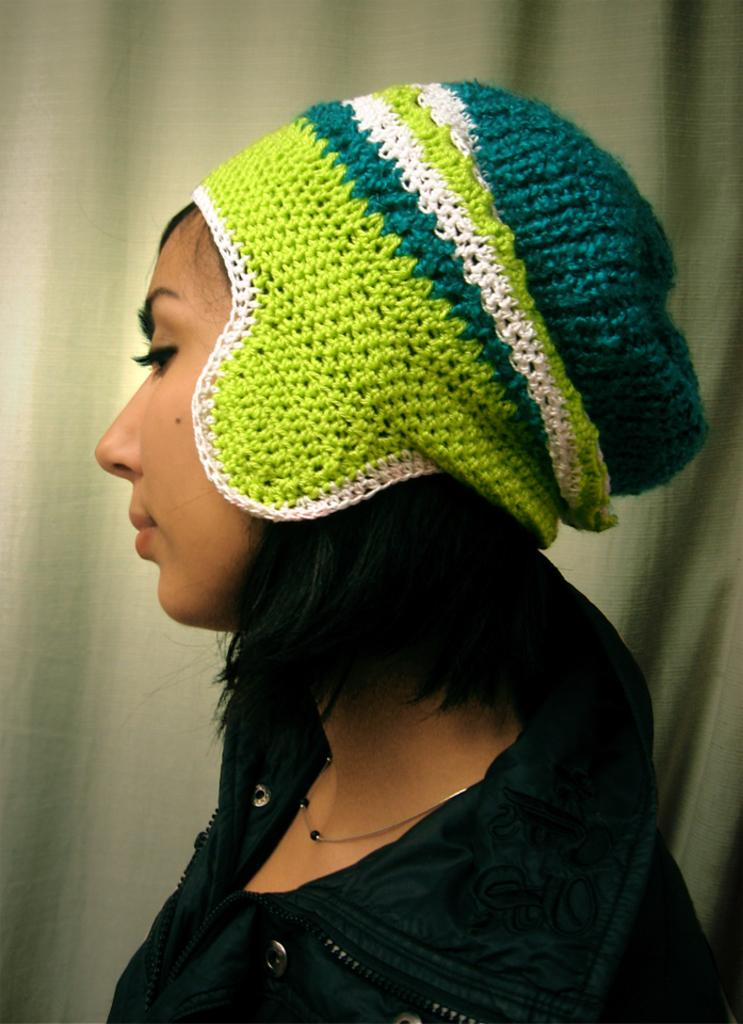Who is the main subject in the picture? There is a woman in the picture. What is the woman wearing on her head? The woman is wearing a cap on her head. What type of clothing is the woman wearing? The woman is wearing a black coat. What can be seen in the background of the picture? There is a curtain in the background of the picture. What type of stitch is the woman using to sew the curtain in the image? There is no stitch or sewing activity present in the image. The woman is not sewing the curtain; she is simply standing in front of it. 